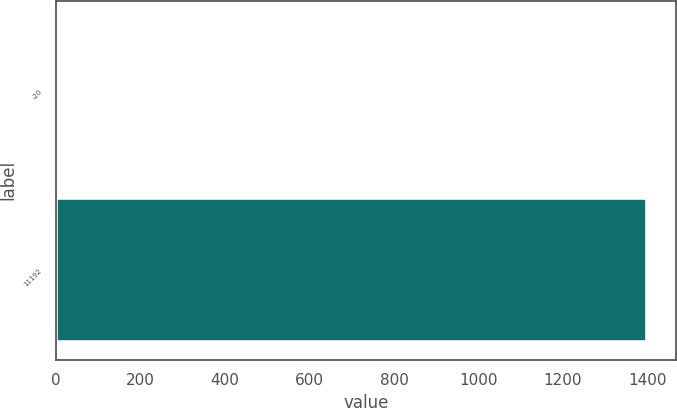Convert chart to OTSL. <chart><loc_0><loc_0><loc_500><loc_500><bar_chart><fcel>-20<fcel>11192<nl><fcel>2.55<fcel>1399.1<nl></chart> 